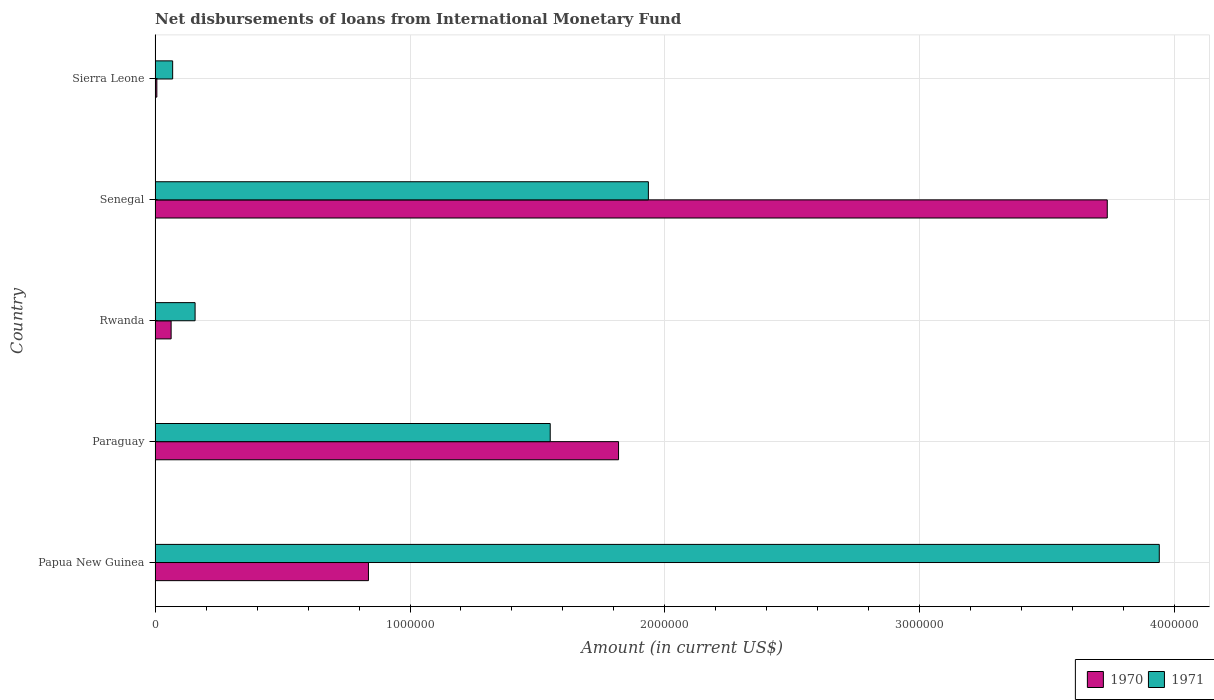Are the number of bars on each tick of the Y-axis equal?
Your response must be concise. Yes. How many bars are there on the 5th tick from the bottom?
Provide a succinct answer. 2. What is the label of the 3rd group of bars from the top?
Your answer should be very brief. Rwanda. What is the amount of loans disbursed in 1970 in Sierra Leone?
Make the answer very short. 7000. Across all countries, what is the maximum amount of loans disbursed in 1971?
Provide a succinct answer. 3.94e+06. Across all countries, what is the minimum amount of loans disbursed in 1971?
Provide a succinct answer. 6.90e+04. In which country was the amount of loans disbursed in 1971 maximum?
Offer a terse response. Papua New Guinea. In which country was the amount of loans disbursed in 1971 minimum?
Your answer should be compact. Sierra Leone. What is the total amount of loans disbursed in 1970 in the graph?
Offer a terse response. 6.46e+06. What is the difference between the amount of loans disbursed in 1970 in Papua New Guinea and that in Sierra Leone?
Make the answer very short. 8.30e+05. What is the difference between the amount of loans disbursed in 1970 in Sierra Leone and the amount of loans disbursed in 1971 in Senegal?
Your answer should be compact. -1.93e+06. What is the average amount of loans disbursed in 1970 per country?
Your answer should be very brief. 1.29e+06. What is the difference between the amount of loans disbursed in 1971 and amount of loans disbursed in 1970 in Paraguay?
Offer a very short reply. -2.68e+05. What is the ratio of the amount of loans disbursed in 1970 in Papua New Guinea to that in Rwanda?
Give a very brief answer. 13.29. Is the amount of loans disbursed in 1970 in Paraguay less than that in Sierra Leone?
Your answer should be very brief. No. What is the difference between the highest and the second highest amount of loans disbursed in 1970?
Make the answer very short. 1.92e+06. What is the difference between the highest and the lowest amount of loans disbursed in 1971?
Ensure brevity in your answer.  3.87e+06. Is the sum of the amount of loans disbursed in 1970 in Senegal and Sierra Leone greater than the maximum amount of loans disbursed in 1971 across all countries?
Ensure brevity in your answer.  No. What does the 1st bar from the top in Papua New Guinea represents?
Make the answer very short. 1971. Are all the bars in the graph horizontal?
Keep it short and to the point. Yes. Does the graph contain any zero values?
Keep it short and to the point. No. Does the graph contain grids?
Your answer should be very brief. Yes. How are the legend labels stacked?
Your response must be concise. Horizontal. What is the title of the graph?
Keep it short and to the point. Net disbursements of loans from International Monetary Fund. What is the Amount (in current US$) in 1970 in Papua New Guinea?
Offer a terse response. 8.37e+05. What is the Amount (in current US$) of 1971 in Papua New Guinea?
Your answer should be very brief. 3.94e+06. What is the Amount (in current US$) of 1970 in Paraguay?
Offer a terse response. 1.82e+06. What is the Amount (in current US$) in 1971 in Paraguay?
Provide a succinct answer. 1.55e+06. What is the Amount (in current US$) of 1970 in Rwanda?
Offer a terse response. 6.30e+04. What is the Amount (in current US$) of 1971 in Rwanda?
Keep it short and to the point. 1.57e+05. What is the Amount (in current US$) in 1970 in Senegal?
Your response must be concise. 3.74e+06. What is the Amount (in current US$) of 1971 in Senegal?
Keep it short and to the point. 1.94e+06. What is the Amount (in current US$) in 1970 in Sierra Leone?
Give a very brief answer. 7000. What is the Amount (in current US$) in 1971 in Sierra Leone?
Provide a short and direct response. 6.90e+04. Across all countries, what is the maximum Amount (in current US$) in 1970?
Keep it short and to the point. 3.74e+06. Across all countries, what is the maximum Amount (in current US$) in 1971?
Your answer should be very brief. 3.94e+06. Across all countries, what is the minimum Amount (in current US$) of 1970?
Give a very brief answer. 7000. Across all countries, what is the minimum Amount (in current US$) of 1971?
Offer a very short reply. 6.90e+04. What is the total Amount (in current US$) of 1970 in the graph?
Provide a succinct answer. 6.46e+06. What is the total Amount (in current US$) in 1971 in the graph?
Your response must be concise. 7.65e+06. What is the difference between the Amount (in current US$) in 1970 in Papua New Guinea and that in Paraguay?
Offer a very short reply. -9.81e+05. What is the difference between the Amount (in current US$) in 1971 in Papua New Guinea and that in Paraguay?
Your response must be concise. 2.39e+06. What is the difference between the Amount (in current US$) of 1970 in Papua New Guinea and that in Rwanda?
Provide a short and direct response. 7.74e+05. What is the difference between the Amount (in current US$) in 1971 in Papua New Guinea and that in Rwanda?
Offer a terse response. 3.78e+06. What is the difference between the Amount (in current US$) of 1970 in Papua New Guinea and that in Senegal?
Ensure brevity in your answer.  -2.90e+06. What is the difference between the Amount (in current US$) of 1971 in Papua New Guinea and that in Senegal?
Make the answer very short. 2.00e+06. What is the difference between the Amount (in current US$) of 1970 in Papua New Guinea and that in Sierra Leone?
Provide a short and direct response. 8.30e+05. What is the difference between the Amount (in current US$) in 1971 in Papua New Guinea and that in Sierra Leone?
Give a very brief answer. 3.87e+06. What is the difference between the Amount (in current US$) of 1970 in Paraguay and that in Rwanda?
Your answer should be compact. 1.76e+06. What is the difference between the Amount (in current US$) in 1971 in Paraguay and that in Rwanda?
Provide a short and direct response. 1.39e+06. What is the difference between the Amount (in current US$) in 1970 in Paraguay and that in Senegal?
Make the answer very short. -1.92e+06. What is the difference between the Amount (in current US$) in 1971 in Paraguay and that in Senegal?
Ensure brevity in your answer.  -3.85e+05. What is the difference between the Amount (in current US$) of 1970 in Paraguay and that in Sierra Leone?
Offer a terse response. 1.81e+06. What is the difference between the Amount (in current US$) of 1971 in Paraguay and that in Sierra Leone?
Provide a succinct answer. 1.48e+06. What is the difference between the Amount (in current US$) of 1970 in Rwanda and that in Senegal?
Keep it short and to the point. -3.67e+06. What is the difference between the Amount (in current US$) in 1971 in Rwanda and that in Senegal?
Offer a very short reply. -1.78e+06. What is the difference between the Amount (in current US$) in 1970 in Rwanda and that in Sierra Leone?
Your answer should be very brief. 5.60e+04. What is the difference between the Amount (in current US$) of 1971 in Rwanda and that in Sierra Leone?
Offer a terse response. 8.80e+04. What is the difference between the Amount (in current US$) of 1970 in Senegal and that in Sierra Leone?
Your answer should be compact. 3.73e+06. What is the difference between the Amount (in current US$) of 1971 in Senegal and that in Sierra Leone?
Provide a short and direct response. 1.87e+06. What is the difference between the Amount (in current US$) of 1970 in Papua New Guinea and the Amount (in current US$) of 1971 in Paraguay?
Your answer should be very brief. -7.13e+05. What is the difference between the Amount (in current US$) in 1970 in Papua New Guinea and the Amount (in current US$) in 1971 in Rwanda?
Give a very brief answer. 6.80e+05. What is the difference between the Amount (in current US$) of 1970 in Papua New Guinea and the Amount (in current US$) of 1971 in Senegal?
Your answer should be very brief. -1.10e+06. What is the difference between the Amount (in current US$) of 1970 in Papua New Guinea and the Amount (in current US$) of 1971 in Sierra Leone?
Your answer should be compact. 7.68e+05. What is the difference between the Amount (in current US$) of 1970 in Paraguay and the Amount (in current US$) of 1971 in Rwanda?
Provide a succinct answer. 1.66e+06. What is the difference between the Amount (in current US$) of 1970 in Paraguay and the Amount (in current US$) of 1971 in Senegal?
Keep it short and to the point. -1.17e+05. What is the difference between the Amount (in current US$) in 1970 in Paraguay and the Amount (in current US$) in 1971 in Sierra Leone?
Offer a very short reply. 1.75e+06. What is the difference between the Amount (in current US$) of 1970 in Rwanda and the Amount (in current US$) of 1971 in Senegal?
Make the answer very short. -1.87e+06. What is the difference between the Amount (in current US$) of 1970 in Rwanda and the Amount (in current US$) of 1971 in Sierra Leone?
Make the answer very short. -6000. What is the difference between the Amount (in current US$) in 1970 in Senegal and the Amount (in current US$) in 1971 in Sierra Leone?
Give a very brief answer. 3.67e+06. What is the average Amount (in current US$) of 1970 per country?
Offer a very short reply. 1.29e+06. What is the average Amount (in current US$) of 1971 per country?
Offer a very short reply. 1.53e+06. What is the difference between the Amount (in current US$) of 1970 and Amount (in current US$) of 1971 in Papua New Guinea?
Ensure brevity in your answer.  -3.10e+06. What is the difference between the Amount (in current US$) of 1970 and Amount (in current US$) of 1971 in Paraguay?
Give a very brief answer. 2.68e+05. What is the difference between the Amount (in current US$) in 1970 and Amount (in current US$) in 1971 in Rwanda?
Offer a terse response. -9.40e+04. What is the difference between the Amount (in current US$) of 1970 and Amount (in current US$) of 1971 in Senegal?
Make the answer very short. 1.80e+06. What is the difference between the Amount (in current US$) of 1970 and Amount (in current US$) of 1971 in Sierra Leone?
Offer a very short reply. -6.20e+04. What is the ratio of the Amount (in current US$) of 1970 in Papua New Guinea to that in Paraguay?
Your answer should be compact. 0.46. What is the ratio of the Amount (in current US$) of 1971 in Papua New Guinea to that in Paraguay?
Your answer should be compact. 2.54. What is the ratio of the Amount (in current US$) of 1970 in Papua New Guinea to that in Rwanda?
Offer a very short reply. 13.29. What is the ratio of the Amount (in current US$) of 1971 in Papua New Guinea to that in Rwanda?
Your answer should be very brief. 25.09. What is the ratio of the Amount (in current US$) of 1970 in Papua New Guinea to that in Senegal?
Your response must be concise. 0.22. What is the ratio of the Amount (in current US$) in 1971 in Papua New Guinea to that in Senegal?
Ensure brevity in your answer.  2.04. What is the ratio of the Amount (in current US$) in 1970 in Papua New Guinea to that in Sierra Leone?
Make the answer very short. 119.57. What is the ratio of the Amount (in current US$) in 1971 in Papua New Guinea to that in Sierra Leone?
Your answer should be very brief. 57.09. What is the ratio of the Amount (in current US$) of 1970 in Paraguay to that in Rwanda?
Provide a short and direct response. 28.86. What is the ratio of the Amount (in current US$) in 1971 in Paraguay to that in Rwanda?
Your answer should be compact. 9.87. What is the ratio of the Amount (in current US$) of 1970 in Paraguay to that in Senegal?
Keep it short and to the point. 0.49. What is the ratio of the Amount (in current US$) of 1971 in Paraguay to that in Senegal?
Your answer should be very brief. 0.8. What is the ratio of the Amount (in current US$) in 1970 in Paraguay to that in Sierra Leone?
Ensure brevity in your answer.  259.71. What is the ratio of the Amount (in current US$) of 1971 in Paraguay to that in Sierra Leone?
Offer a terse response. 22.46. What is the ratio of the Amount (in current US$) of 1970 in Rwanda to that in Senegal?
Give a very brief answer. 0.02. What is the ratio of the Amount (in current US$) in 1971 in Rwanda to that in Senegal?
Give a very brief answer. 0.08. What is the ratio of the Amount (in current US$) in 1971 in Rwanda to that in Sierra Leone?
Provide a succinct answer. 2.28. What is the ratio of the Amount (in current US$) of 1970 in Senegal to that in Sierra Leone?
Your answer should be compact. 533.57. What is the ratio of the Amount (in current US$) of 1971 in Senegal to that in Sierra Leone?
Give a very brief answer. 28.04. What is the difference between the highest and the second highest Amount (in current US$) in 1970?
Offer a very short reply. 1.92e+06. What is the difference between the highest and the second highest Amount (in current US$) of 1971?
Your response must be concise. 2.00e+06. What is the difference between the highest and the lowest Amount (in current US$) of 1970?
Provide a succinct answer. 3.73e+06. What is the difference between the highest and the lowest Amount (in current US$) in 1971?
Give a very brief answer. 3.87e+06. 